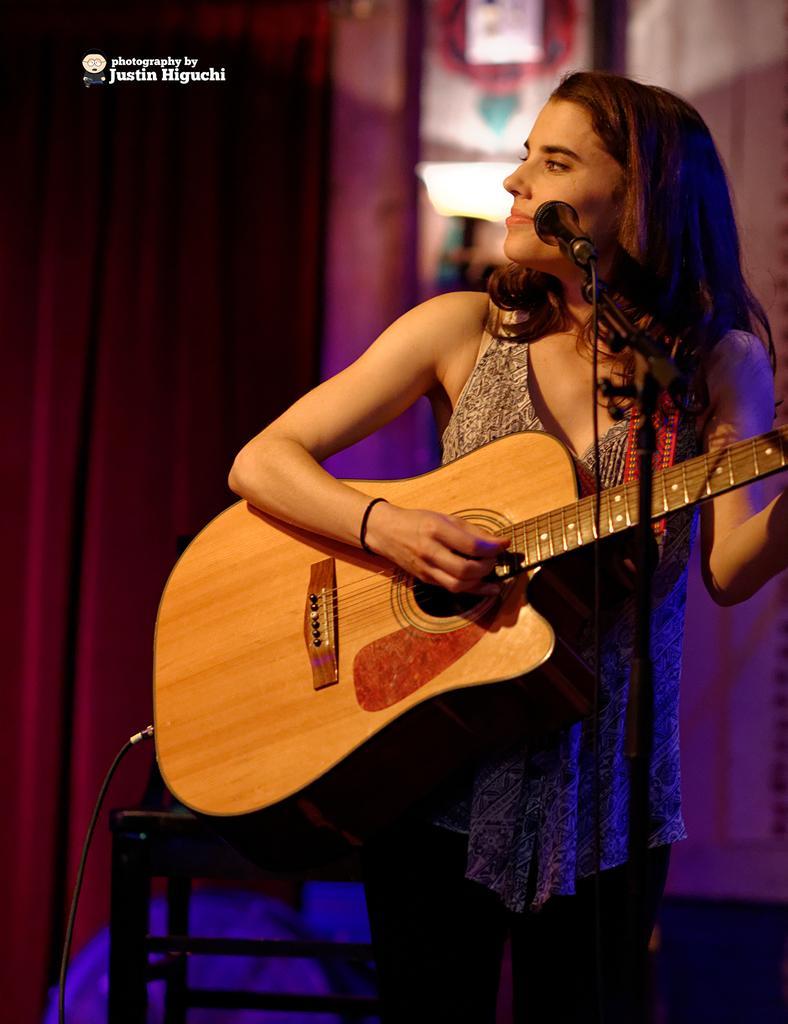Please provide a concise description of this image. In this picture we can see woman holding guitar in her hands and playing it and in front of her there is mic and in background we can see curtains and it is blurry. 